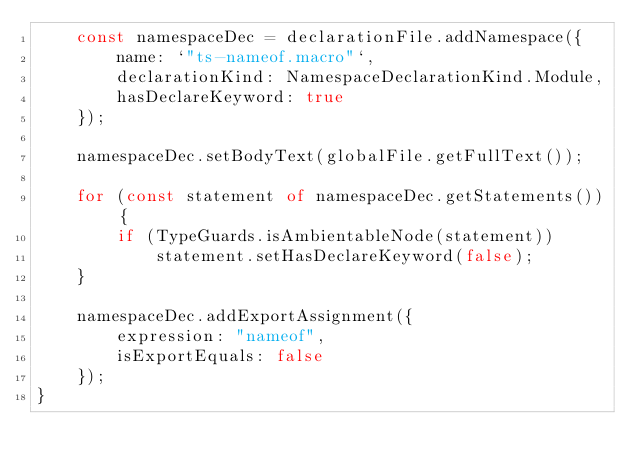<code> <loc_0><loc_0><loc_500><loc_500><_TypeScript_>    const namespaceDec = declarationFile.addNamespace({
        name: `"ts-nameof.macro"`,
        declarationKind: NamespaceDeclarationKind.Module,
        hasDeclareKeyword: true
    });

    namespaceDec.setBodyText(globalFile.getFullText());

    for (const statement of namespaceDec.getStatements()) {
        if (TypeGuards.isAmbientableNode(statement))
            statement.setHasDeclareKeyword(false);
    }

    namespaceDec.addExportAssignment({
        expression: "nameof",
        isExportEquals: false
    });
}
</code> 